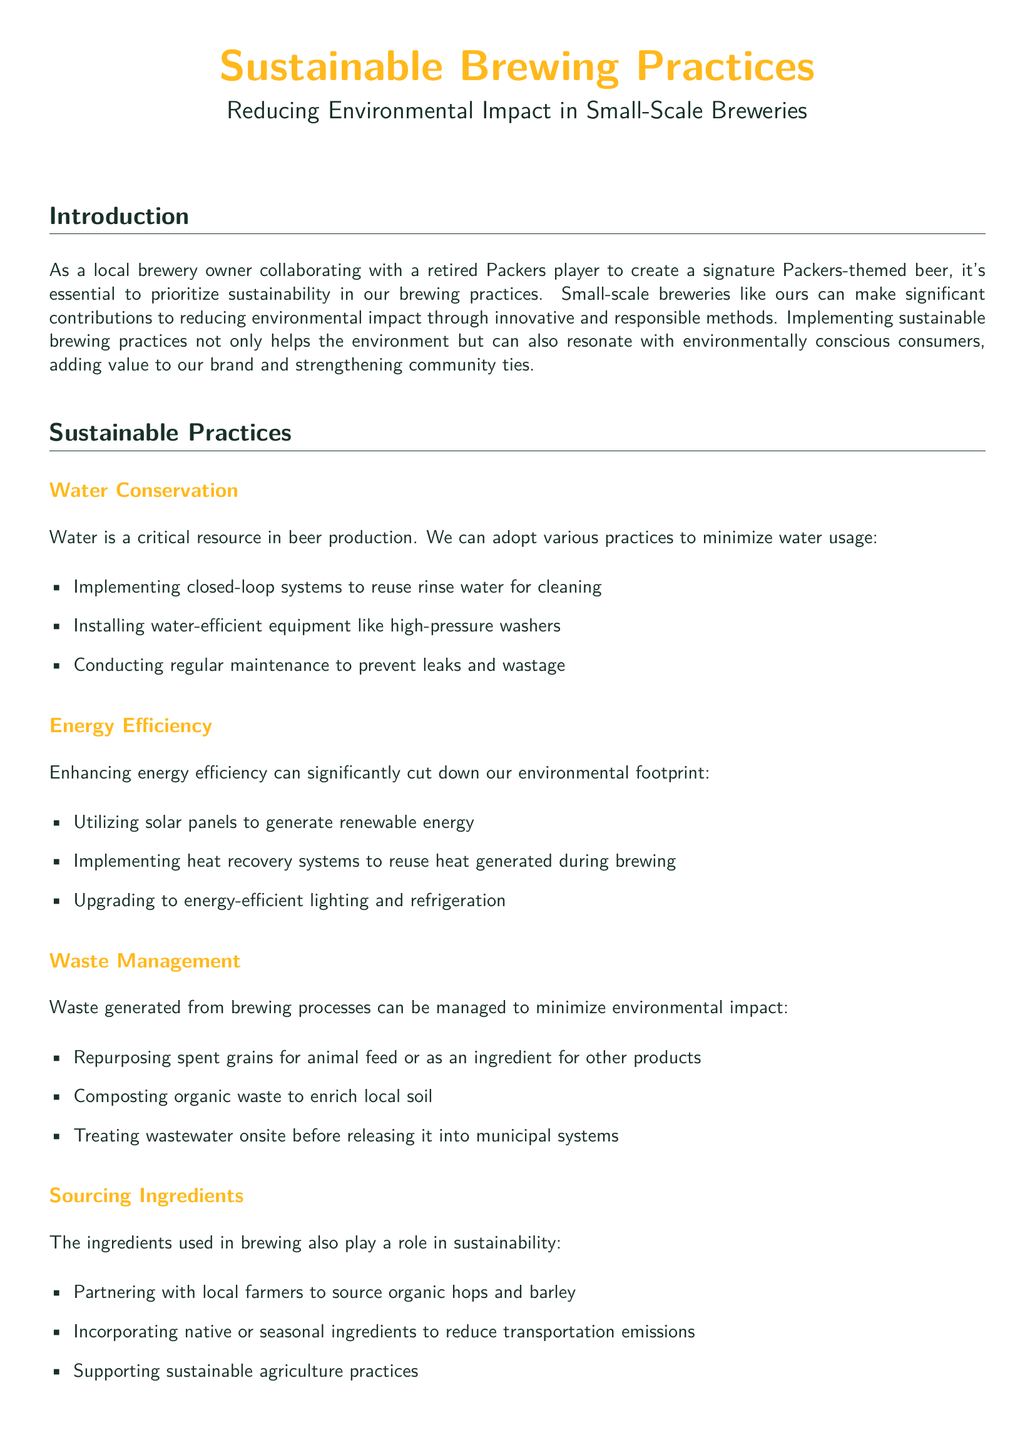What is the title of the whitepaper? The title of the whitepaper is prominently displayed at the beginning.
Answer: Sustainable Brewing Practices What is the main focus of this document? The main focus is provided in the introduction section.
Answer: Reducing Environmental Impact in Small-Scale Breweries Which color is associated with the Packers in the document? The colors mentioned in the document are described in the preamble and title color settings.
Answer: Packer Green What is one method for water conservation mentioned? Listed practices for water conservation can be found in the water conservation section.
Answer: Implementing closed-loop systems What ingredient sourcing strategy is suggested? The document provides several approaches under the sourcing ingredients section.
Answer: Partnering with local farmers What waste management practice is recommended? Specific waste management practices are detailed in their respective section.
Answer: Repurposing spent grains How can energy efficiency be improved according to the document? The document outlines methods for enhancing energy efficiency.
Answer: Utilizing solar panels What is the overall purpose of integrating sustainable practices? The conclusion summarizes the benefits of sustainable practices for the brewery.
Answer: Contribute positively to the environment 